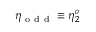<formula> <loc_0><loc_0><loc_500><loc_500>\eta _ { o d d } \equiv \eta _ { 2 } ^ { o }</formula> 